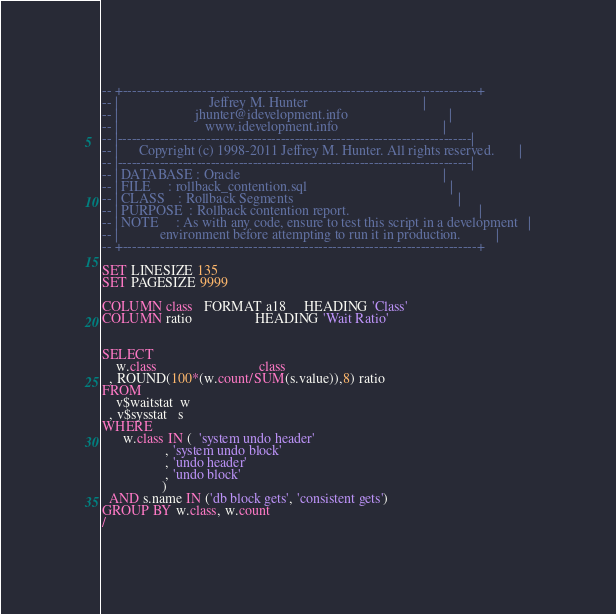<code> <loc_0><loc_0><loc_500><loc_500><_SQL_>-- +----------------------------------------------------------------------------+
-- |                          Jeffrey M. Hunter                                 |
-- |                      jhunter@idevelopment.info                             |
-- |                         www.idevelopment.info                              |
-- |----------------------------------------------------------------------------|
-- |      Copyright (c) 1998-2011 Jeffrey M. Hunter. All rights reserved.       |
-- |----------------------------------------------------------------------------|
-- | DATABASE : Oracle                                                          |
-- | FILE     : rollback_contention.sql                                         |
-- | CLASS    : Rollback Segments                                               |
-- | PURPOSE  : Rollback contention report.                                     |
-- | NOTE     : As with any code, ensure to test this script in a development   |
-- |            environment before attempting to run it in production.          |
-- +----------------------------------------------------------------------------+

SET LINESIZE 135
SET PAGESIZE 9999

COLUMN class   FORMAT a18     HEADING 'Class'    
COLUMN ratio                  HEADING 'Wait Ratio'       


SELECT
    w.class                             class
  , ROUND(100*(w.count/SUM(s.value)),8) ratio
FROM
    v$waitstat  w
  , v$sysstat   s
WHERE
      w.class IN (  'system undo header'
                  , 'system undo block'
                  , 'undo header'
                  , 'undo block'
                 )
  AND s.name IN ('db block gets', 'consistent gets')
GROUP BY w.class, w.count
/

</code> 